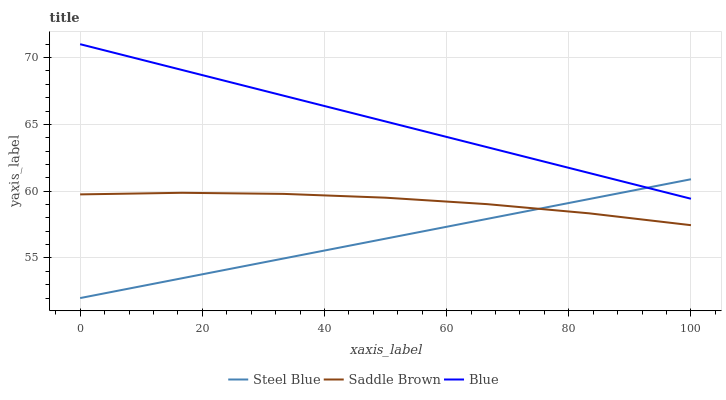Does Saddle Brown have the minimum area under the curve?
Answer yes or no. No. Does Saddle Brown have the maximum area under the curve?
Answer yes or no. No. Is Steel Blue the smoothest?
Answer yes or no. No. Is Steel Blue the roughest?
Answer yes or no. No. Does Saddle Brown have the lowest value?
Answer yes or no. No. Does Steel Blue have the highest value?
Answer yes or no. No. Is Saddle Brown less than Blue?
Answer yes or no. Yes. Is Blue greater than Saddle Brown?
Answer yes or no. Yes. Does Saddle Brown intersect Blue?
Answer yes or no. No. 